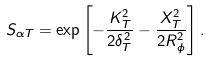Convert formula to latex. <formula><loc_0><loc_0><loc_500><loc_500>S _ { \alpha T } = \exp \left [ - \frac { K _ { T } ^ { 2 } } { 2 \delta _ { T } ^ { 2 } } - \frac { X _ { T } ^ { 2 } } { 2 R _ { \phi } ^ { 2 } } \right ] .</formula> 